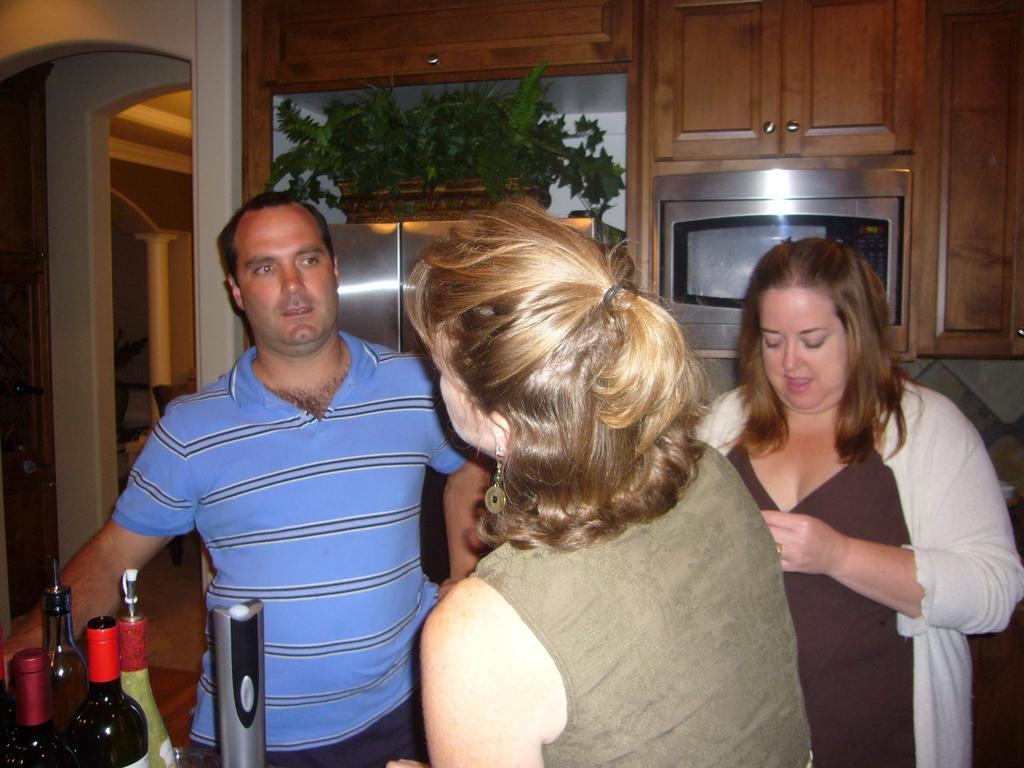How many people are present in the room in the image? There are three persons standing in the room. What can be seen in the background of the image? There are bottles, a micro-oven, a cupboard, and a flower pot in the background. Can you describe the objects in the background? The background features bottles, a micro-oven, a cupboard, and a flower pot. What type of cloth is the user wearing in the image? The provided facts do not mention any clothing or fabric in the image, so it cannot be determined from the image. 